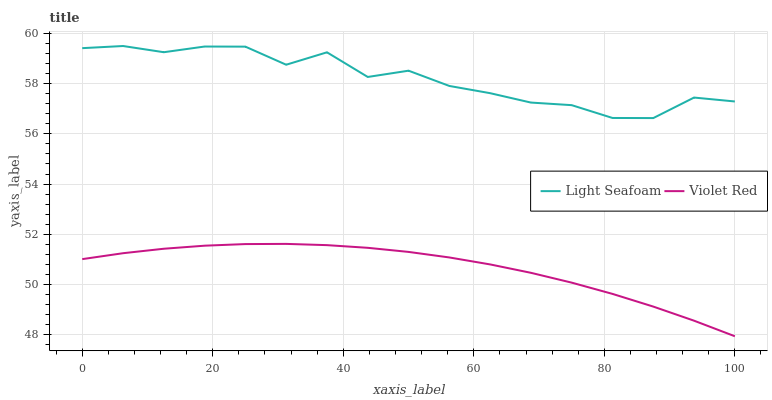Does Violet Red have the minimum area under the curve?
Answer yes or no. Yes. Does Light Seafoam have the maximum area under the curve?
Answer yes or no. Yes. Does Light Seafoam have the minimum area under the curve?
Answer yes or no. No. Is Violet Red the smoothest?
Answer yes or no. Yes. Is Light Seafoam the roughest?
Answer yes or no. Yes. Is Light Seafoam the smoothest?
Answer yes or no. No. Does Violet Red have the lowest value?
Answer yes or no. Yes. Does Light Seafoam have the lowest value?
Answer yes or no. No. Does Light Seafoam have the highest value?
Answer yes or no. Yes. Is Violet Red less than Light Seafoam?
Answer yes or no. Yes. Is Light Seafoam greater than Violet Red?
Answer yes or no. Yes. Does Violet Red intersect Light Seafoam?
Answer yes or no. No. 